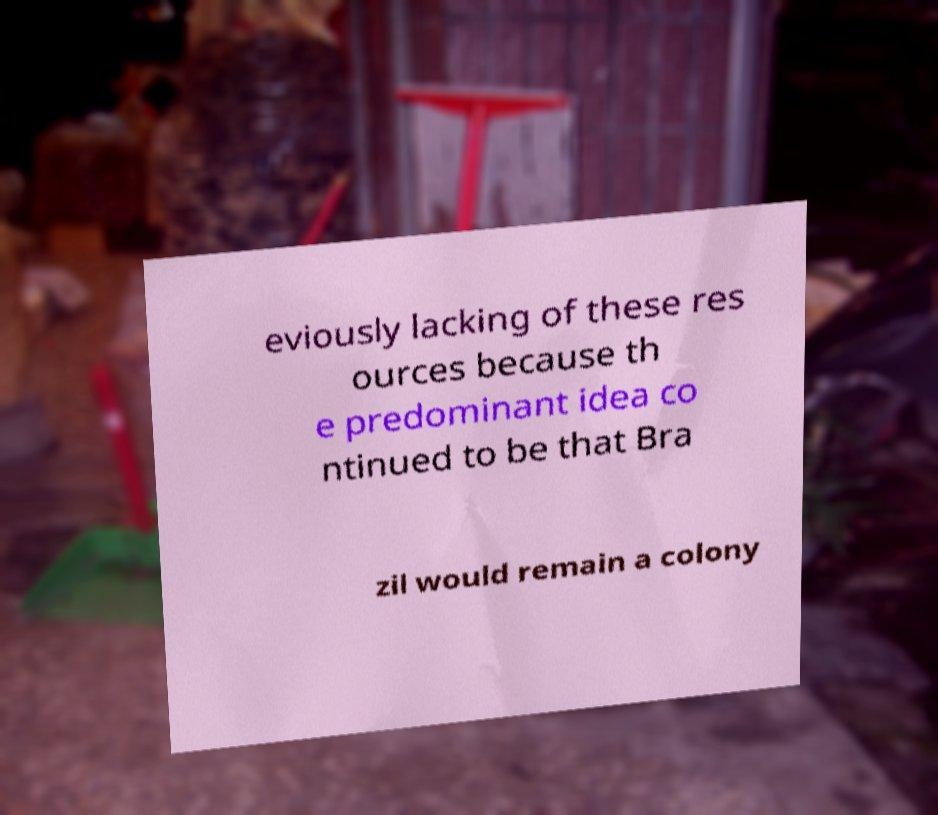What messages or text are displayed in this image? I need them in a readable, typed format. eviously lacking of these res ources because th e predominant idea co ntinued to be that Bra zil would remain a colony 